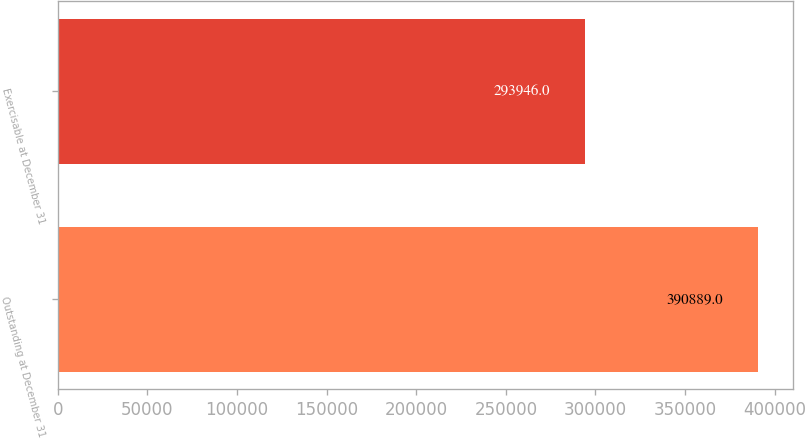<chart> <loc_0><loc_0><loc_500><loc_500><bar_chart><fcel>Outstanding at December 31<fcel>Exercisable at December 31<nl><fcel>390889<fcel>293946<nl></chart> 